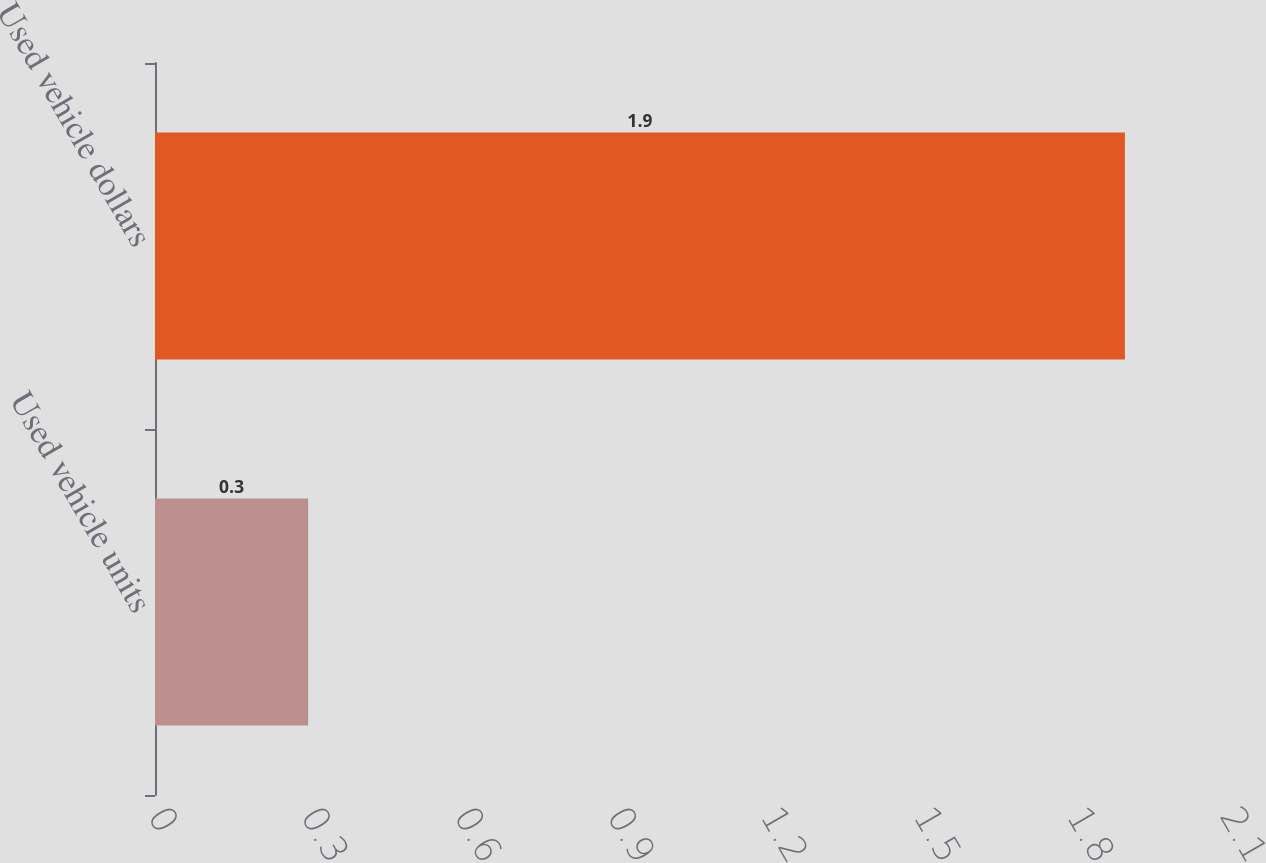Convert chart to OTSL. <chart><loc_0><loc_0><loc_500><loc_500><bar_chart><fcel>Used vehicle units<fcel>Used vehicle dollars<nl><fcel>0.3<fcel>1.9<nl></chart> 